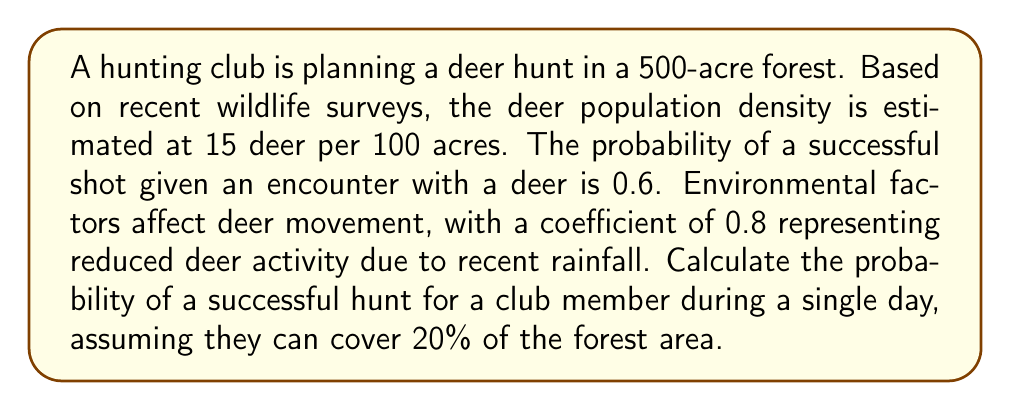Give your solution to this math problem. Let's approach this problem step-by-step:

1) First, calculate the total number of deer in the forest:
   $$ \text{Total deer} = \frac{500 \text{ acres}}{100 \text{ acres}} \times 15 \text{ deer} = 75 \text{ deer} $$

2) The area a hunter can cover in a day:
   $$ \text{Area covered} = 20\% \times 500 \text{ acres} = 100 \text{ acres} $$

3) The expected number of deer in the covered area:
   $$ \text{Expected deer} = \frac{100 \text{ acres}}{500 \text{ acres}} \times 75 \text{ deer} = 15 \text{ deer} $$

4) Adjust for environmental factors:
   $$ \text{Adjusted deer} = 15 \text{ deer} \times 0.8 = 12 \text{ deer} $$

5) The probability of encountering at least one deer follows a Poisson distribution:
   $$ P(\text{at least one encounter}) = 1 - P(\text{no encounters}) = 1 - e^{-\lambda} $$
   where $\lambda$ is the expected number of encounters (12 in this case).

6) Calculate the probability of at least one encounter:
   $$ P(\text{at least one encounter}) = 1 - e^{-12} \approx 0.999994 $$

7) The probability of a successful hunt is the product of the probability of an encounter and the probability of a successful shot:
   $$ P(\text{successful hunt}) = P(\text{at least one encounter}) \times P(\text{successful shot}) $$
   $$ P(\text{successful hunt}) = 0.999994 \times 0.6 \approx 0.5999964 $$
Answer: 0.60 